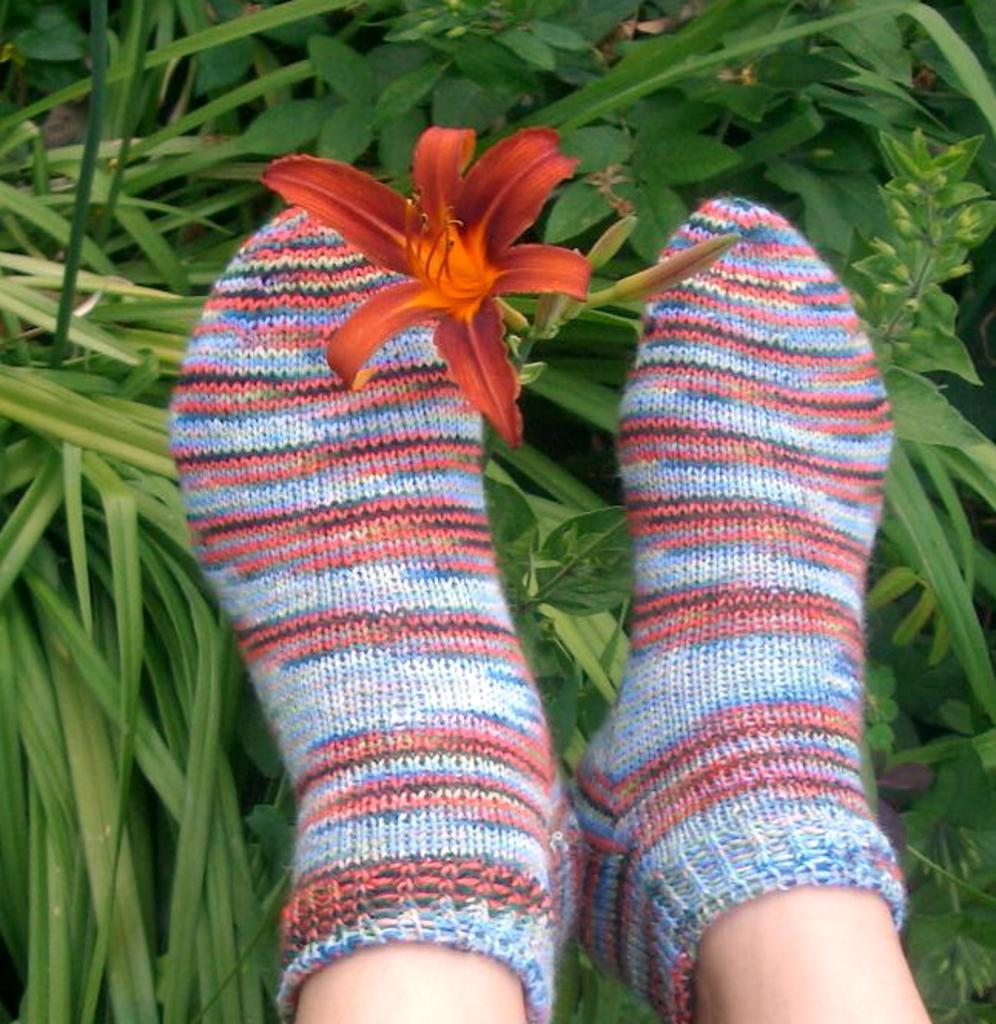Describe this image in one or two sentences. In the picture I can see a person's leg wearing woolen socks. Here I can see a red color flower and in the background, I can see some plants. 